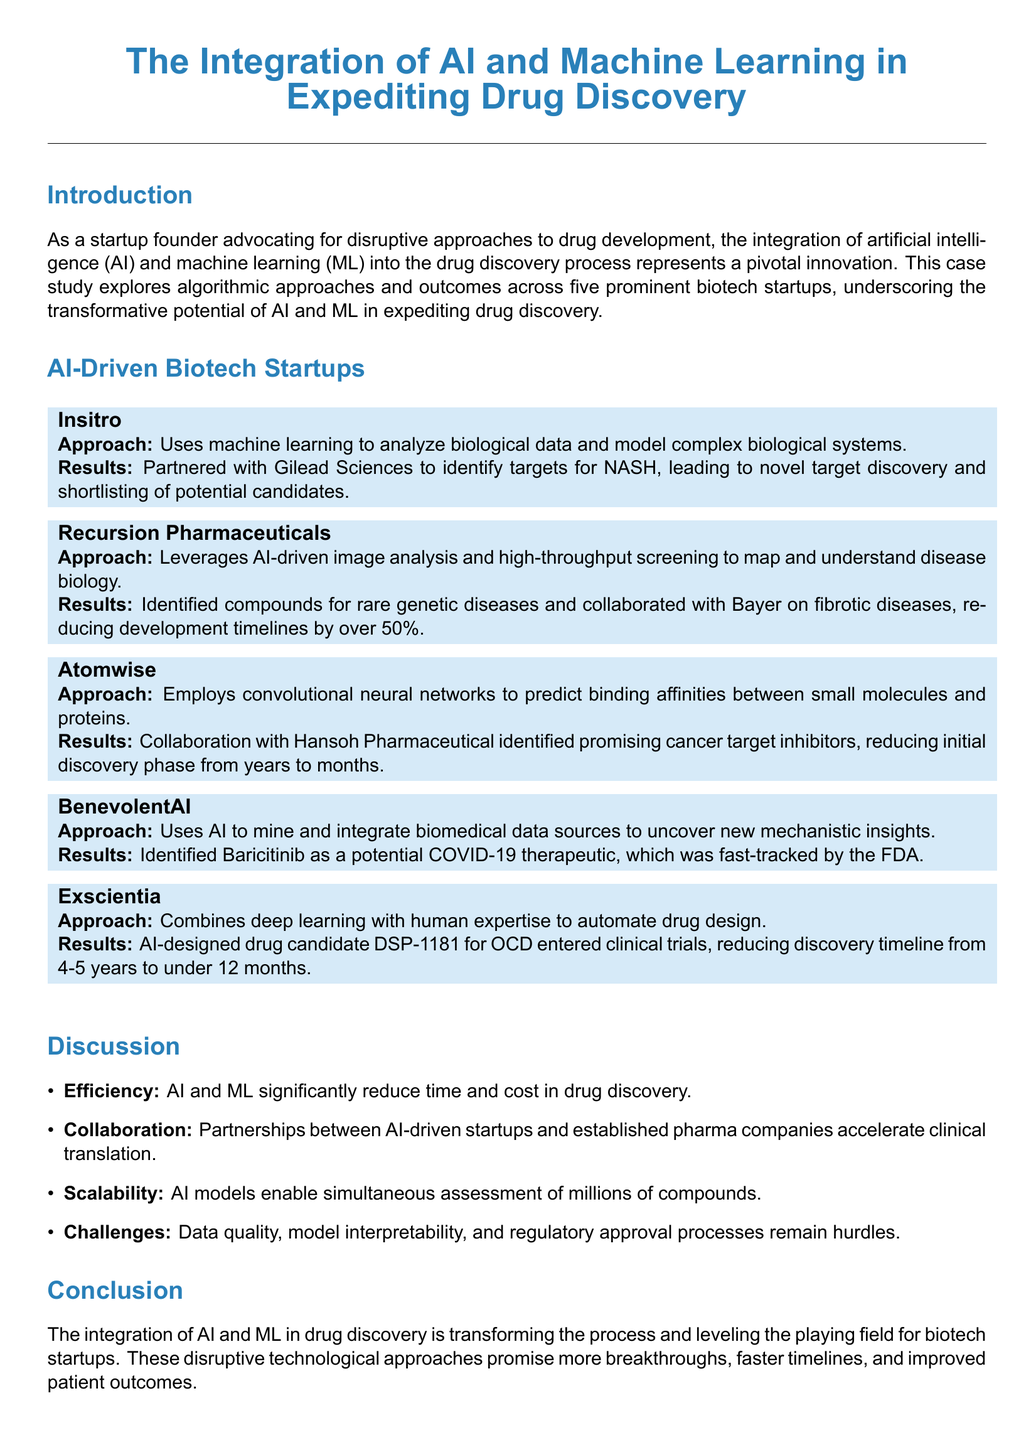What is the name of the case study? The case study's title is given at the beginning of the document, which describes a focus on AI and machine learning in drug discovery.
Answer: The Integration of AI and Machine Learning in Expediting Drug Discovery How many biotech startups are examined in the case study? The document specifies that five biotech startups are explored regarding their algorithmic approaches.
Answer: Five Which company partnered with Insitro? The document lists Gilead Sciences as the partner of Insitro for target discovery.
Answer: Gilead Sciences What drug candidate developed by Exscientia entered clinical trials? The document mentions a specific drug candidate DSP-1181 that was developed by Exscientia.
Answer: DSP-1181 What is a significant challenge mentioned in the document? The text outlines hurdles in drug discovery, including issues related to data quality and model interpretability.
Answer: Data quality Which startup identified Baricitinib for COVID-19? The case study states that BenevolentAI identified Baricitinib as a potential therapeutic for COVID-19.
Answer: BenevolentAI What is the main benefit of AI and ML in drug discovery according to the discussion? The document emphasizes that AI and ML significantly enhance efficiency in time and cost reduction during drug development.
Answer: Efficiency What is the result of Atomwise's collaboration with Hansoh Pharmaceutical? The document indicates that Atomwise’s collaboration led to promising cancer target inhibitors, showing a shift in the time frame for drug discovery.
Answer: Reduced initial discovery phase from years to months What type of analysis does Recursion Pharmaceuticals leverage? The document specifies that Recursion Pharmaceuticals employs AI-driven image analysis and high-throughput screening in its processes.
Answer: AI-driven image analysis and high-throughput screening 